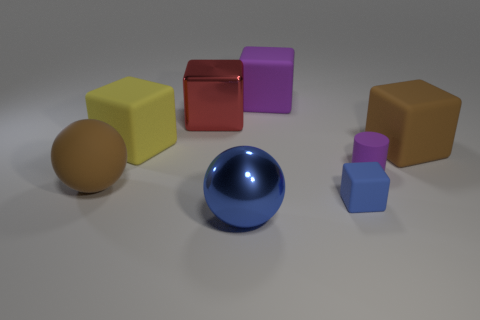Subtract all red blocks. How many blocks are left? 4 Subtract all big yellow blocks. How many blocks are left? 4 Subtract all gray blocks. Subtract all red cylinders. How many blocks are left? 5 Add 1 large matte balls. How many objects exist? 9 Subtract all cylinders. How many objects are left? 7 Subtract all large cyan metal blocks. Subtract all purple objects. How many objects are left? 6 Add 4 red metal objects. How many red metal objects are left? 5 Add 2 large cyan matte objects. How many large cyan matte objects exist? 2 Subtract 0 brown cylinders. How many objects are left? 8 